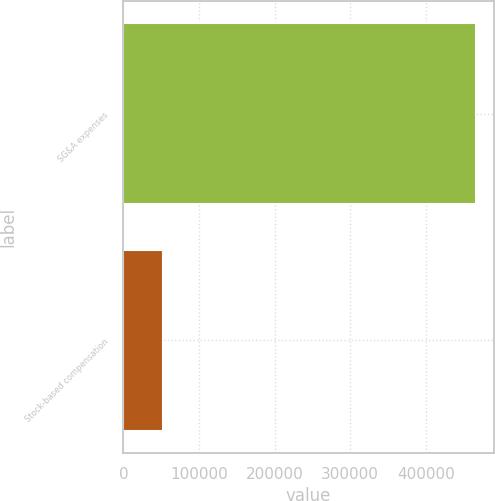<chart> <loc_0><loc_0><loc_500><loc_500><bar_chart><fcel>SG&A expenses<fcel>Stock-based compensation<nl><fcel>466951<fcel>51806<nl></chart> 